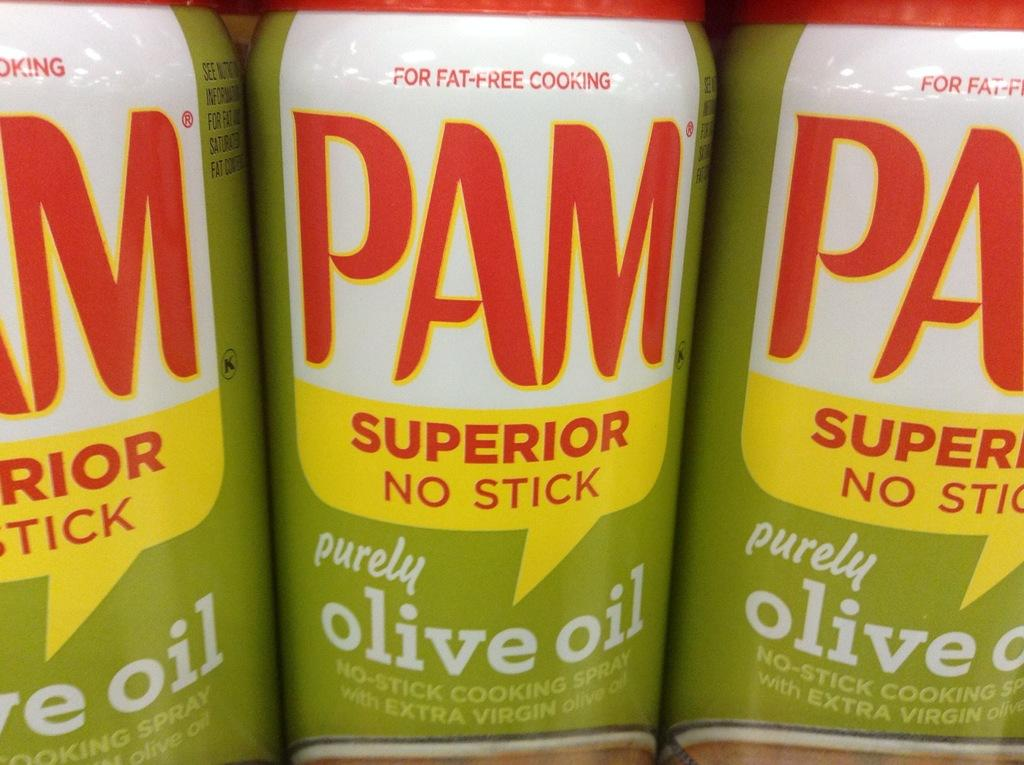What objects can be seen in the image? There are bottles in the image. What information is provided on the bottles? There is text written on the bottles. What type of arch can be seen in the image? There is no arch present in the image; it only features bottles with text written on them. 